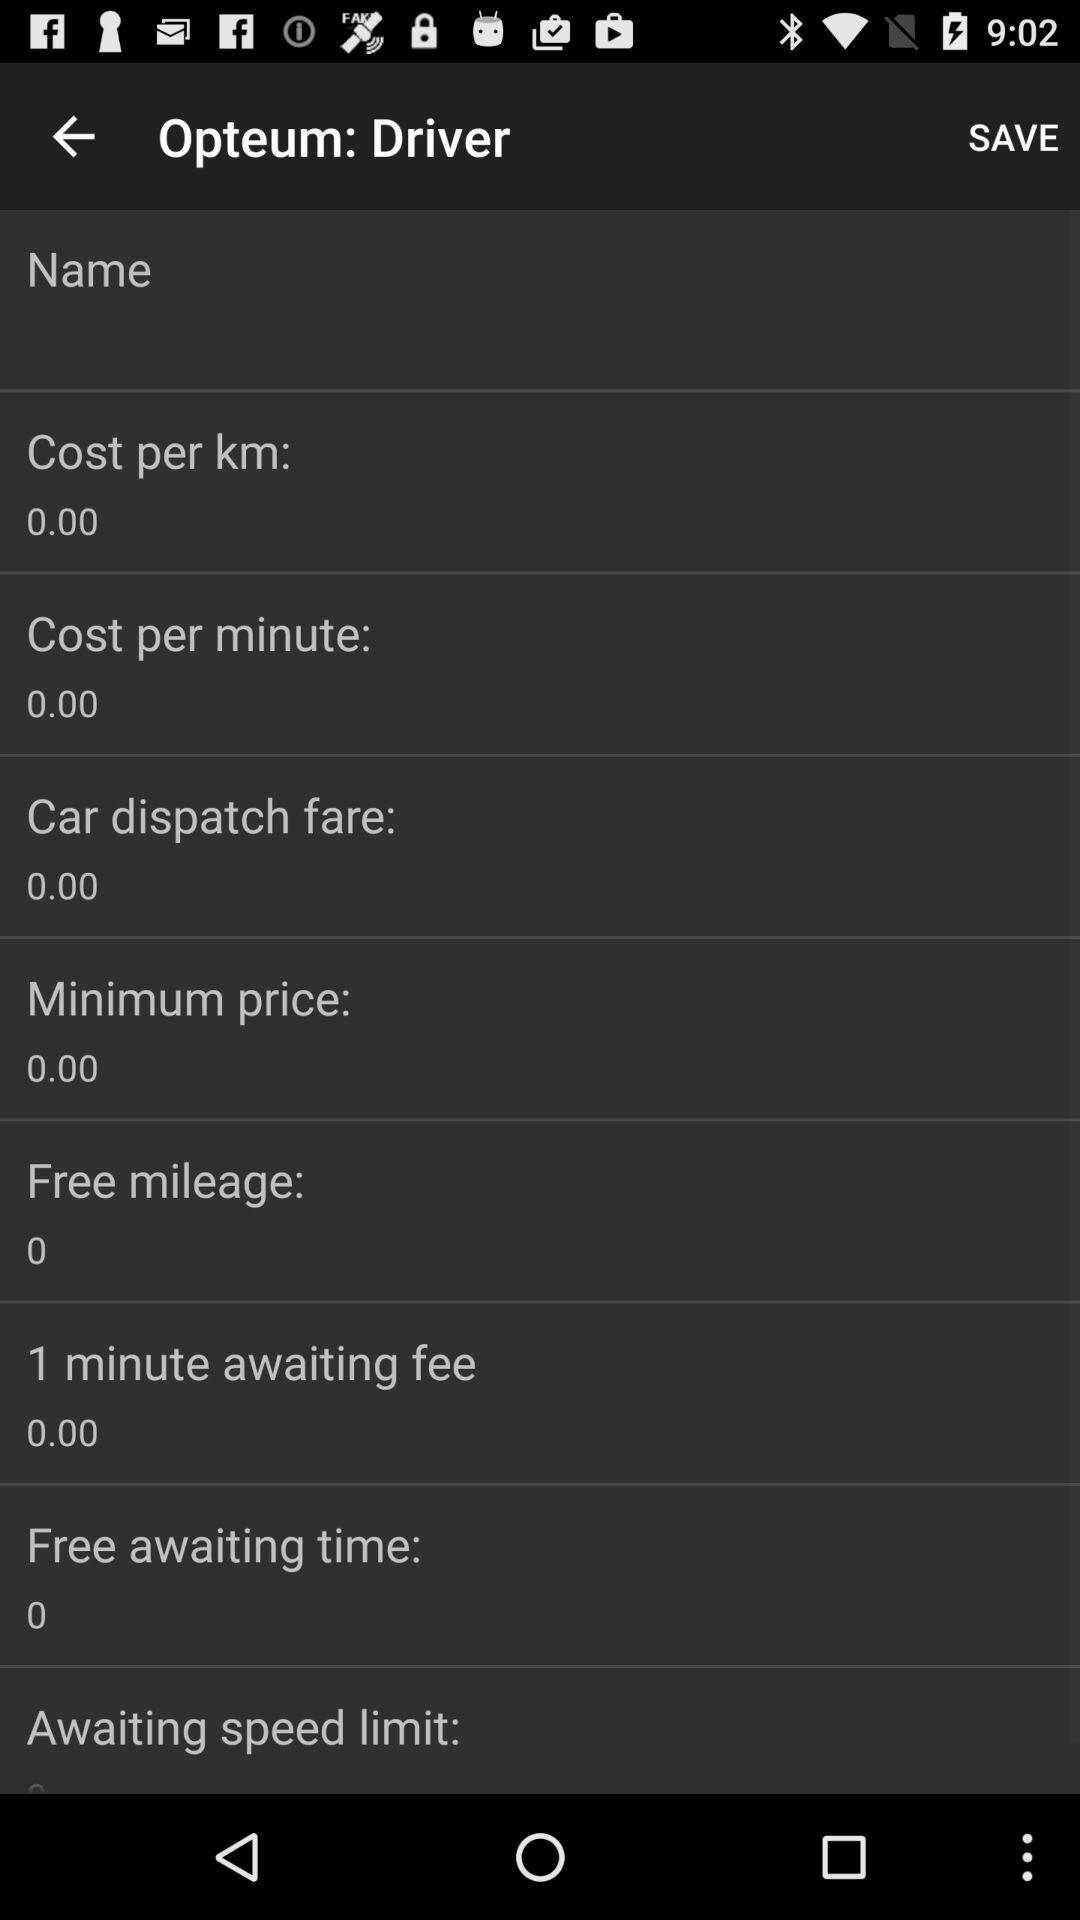How much is the free mileage?
Answer the question using a single word or phrase. 0 